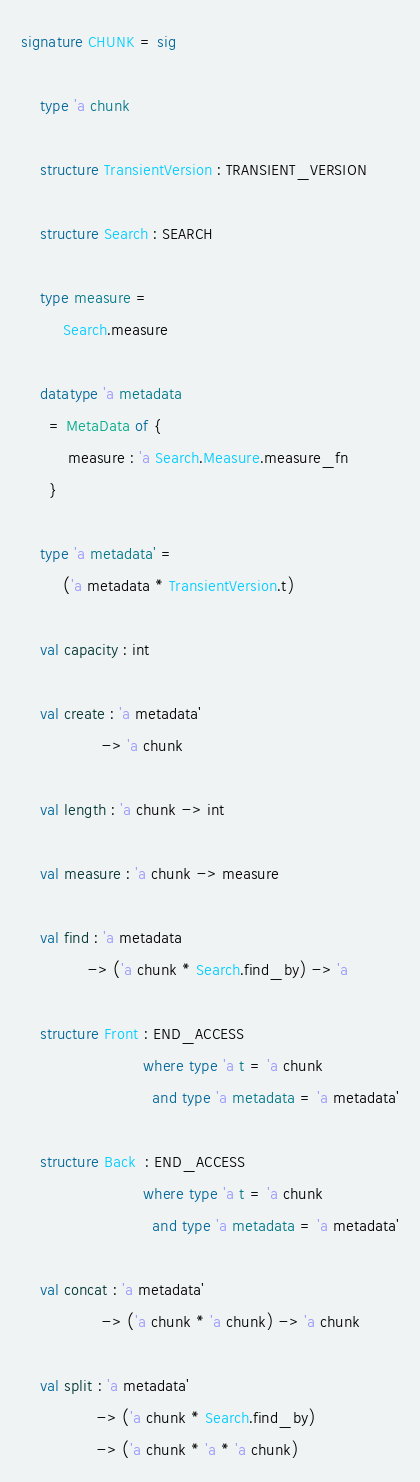Convert code to text. <code><loc_0><loc_0><loc_500><loc_500><_SML_>signature CHUNK = sig
    
    type 'a chunk

    structure TransientVersion : TRANSIENT_VERSION

    structure Search : SEARCH

    type measure =
         Search.measure

    datatype 'a metadata
      = MetaData of {
          measure : 'a Search.Measure.measure_fn
      }

    type 'a metadata' =
         ('a metadata * TransientVersion.t)

    val capacity : int

    val create : 'a metadata'
                 -> 'a chunk

    val length : 'a chunk -> int

    val measure : 'a chunk -> measure

    val find : 'a metadata
              -> ('a chunk * Search.find_by) -> 'a
                                                    
    structure Front : END_ACCESS
                          where type 'a t = 'a chunk
                            and type 'a metadata = 'a metadata'

    structure Back  : END_ACCESS
                          where type 'a t = 'a chunk
                            and type 'a metadata = 'a metadata'
                                       
    val concat : 'a metadata'
                 -> ('a chunk * 'a chunk) -> 'a chunk

    val split : 'a metadata'
                -> ('a chunk * Search.find_by)
                -> ('a chunk * 'a * 'a chunk)
</code> 